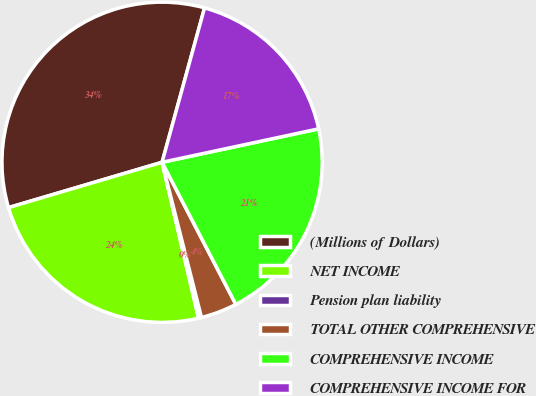Convert chart. <chart><loc_0><loc_0><loc_500><loc_500><pie_chart><fcel>(Millions of Dollars)<fcel>NET INCOME<fcel>Pension plan liability<fcel>TOTAL OTHER COMPREHENSIVE<fcel>COMPREHENSIVE INCOME<fcel>COMPREHENSIVE INCOME FOR<nl><fcel>33.84%<fcel>24.09%<fcel>0.3%<fcel>3.66%<fcel>20.73%<fcel>17.38%<nl></chart> 